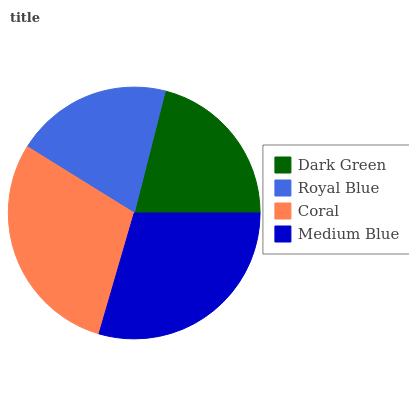Is Royal Blue the minimum?
Answer yes or no. Yes. Is Medium Blue the maximum?
Answer yes or no. Yes. Is Coral the minimum?
Answer yes or no. No. Is Coral the maximum?
Answer yes or no. No. Is Coral greater than Royal Blue?
Answer yes or no. Yes. Is Royal Blue less than Coral?
Answer yes or no. Yes. Is Royal Blue greater than Coral?
Answer yes or no. No. Is Coral less than Royal Blue?
Answer yes or no. No. Is Coral the high median?
Answer yes or no. Yes. Is Dark Green the low median?
Answer yes or no. Yes. Is Medium Blue the high median?
Answer yes or no. No. Is Medium Blue the low median?
Answer yes or no. No. 